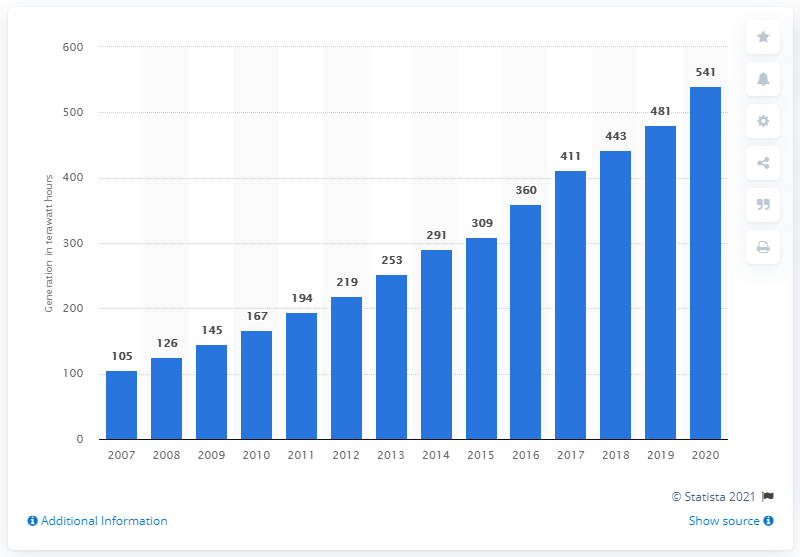Draw attention to some important aspects in this diagram. In 2014, the generation of non-hydropower renewable energy surpassed hydropower for the first time, marking a significant milestone in the shift towards a cleaner and more sustainable energy mix. 